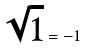Convert formula to latex. <formula><loc_0><loc_0><loc_500><loc_500>\sqrt { 1 } = - 1</formula> 